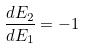<formula> <loc_0><loc_0><loc_500><loc_500>\frac { d E _ { 2 } } { d E _ { 1 } } = - 1</formula> 